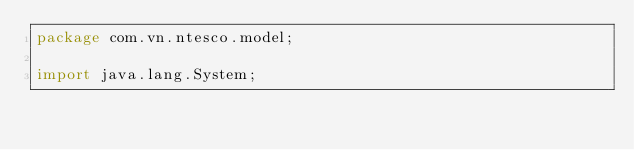Convert code to text. <code><loc_0><loc_0><loc_500><loc_500><_Java_>package com.vn.ntesco.model;

import java.lang.System;
</code> 